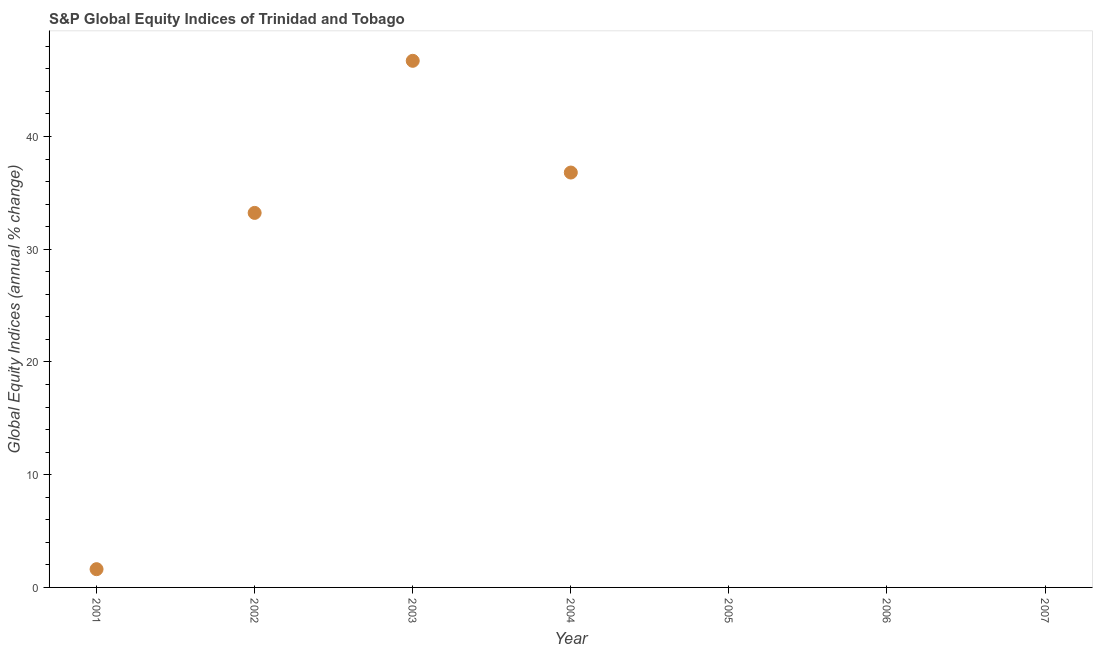Across all years, what is the maximum s&p global equity indices?
Your answer should be compact. 46.71. What is the sum of the s&p global equity indices?
Make the answer very short. 118.35. What is the difference between the s&p global equity indices in 2002 and 2004?
Your response must be concise. -3.58. What is the average s&p global equity indices per year?
Your answer should be very brief. 16.91. What is the median s&p global equity indices?
Offer a very short reply. 1.62. Is the difference between the s&p global equity indices in 2002 and 2004 greater than the difference between any two years?
Your answer should be very brief. No. What is the difference between the highest and the second highest s&p global equity indices?
Provide a succinct answer. 9.91. What is the difference between the highest and the lowest s&p global equity indices?
Provide a short and direct response. 46.71. In how many years, is the s&p global equity indices greater than the average s&p global equity indices taken over all years?
Make the answer very short. 3. Does the s&p global equity indices monotonically increase over the years?
Provide a succinct answer. No. How many dotlines are there?
Make the answer very short. 1. How many years are there in the graph?
Ensure brevity in your answer.  7. Are the values on the major ticks of Y-axis written in scientific E-notation?
Give a very brief answer. No. What is the title of the graph?
Make the answer very short. S&P Global Equity Indices of Trinidad and Tobago. What is the label or title of the X-axis?
Keep it short and to the point. Year. What is the label or title of the Y-axis?
Your answer should be compact. Global Equity Indices (annual % change). What is the Global Equity Indices (annual % change) in 2001?
Your response must be concise. 1.62. What is the Global Equity Indices (annual % change) in 2002?
Offer a terse response. 33.22. What is the Global Equity Indices (annual % change) in 2003?
Offer a very short reply. 46.71. What is the Global Equity Indices (annual % change) in 2004?
Ensure brevity in your answer.  36.8. What is the Global Equity Indices (annual % change) in 2006?
Your answer should be very brief. 0. What is the difference between the Global Equity Indices (annual % change) in 2001 and 2002?
Keep it short and to the point. -31.6. What is the difference between the Global Equity Indices (annual % change) in 2001 and 2003?
Ensure brevity in your answer.  -45.09. What is the difference between the Global Equity Indices (annual % change) in 2001 and 2004?
Make the answer very short. -35.18. What is the difference between the Global Equity Indices (annual % change) in 2002 and 2003?
Offer a terse response. -13.49. What is the difference between the Global Equity Indices (annual % change) in 2002 and 2004?
Provide a succinct answer. -3.58. What is the difference between the Global Equity Indices (annual % change) in 2003 and 2004?
Your answer should be compact. 9.91. What is the ratio of the Global Equity Indices (annual % change) in 2001 to that in 2002?
Offer a very short reply. 0.05. What is the ratio of the Global Equity Indices (annual % change) in 2001 to that in 2003?
Your answer should be compact. 0.04. What is the ratio of the Global Equity Indices (annual % change) in 2001 to that in 2004?
Keep it short and to the point. 0.04. What is the ratio of the Global Equity Indices (annual % change) in 2002 to that in 2003?
Give a very brief answer. 0.71. What is the ratio of the Global Equity Indices (annual % change) in 2002 to that in 2004?
Give a very brief answer. 0.9. What is the ratio of the Global Equity Indices (annual % change) in 2003 to that in 2004?
Ensure brevity in your answer.  1.27. 